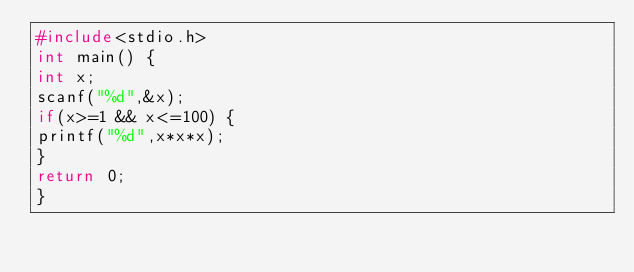<code> <loc_0><loc_0><loc_500><loc_500><_C_>#include<stdio.h>
int main() {
int x;
scanf("%d",&x);
if(x>=1 && x<=100) {
printf("%d",x*x*x);
}
return 0;
}</code> 